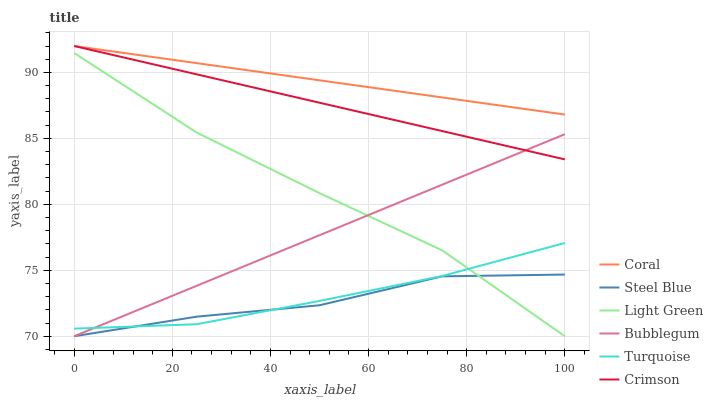Does Steel Blue have the minimum area under the curve?
Answer yes or no. Yes. Does Coral have the maximum area under the curve?
Answer yes or no. Yes. Does Coral have the minimum area under the curve?
Answer yes or no. No. Does Steel Blue have the maximum area under the curve?
Answer yes or no. No. Is Coral the smoothest?
Answer yes or no. Yes. Is Steel Blue the roughest?
Answer yes or no. Yes. Is Steel Blue the smoothest?
Answer yes or no. No. Is Coral the roughest?
Answer yes or no. No. Does Steel Blue have the lowest value?
Answer yes or no. Yes. Does Coral have the lowest value?
Answer yes or no. No. Does Crimson have the highest value?
Answer yes or no. Yes. Does Steel Blue have the highest value?
Answer yes or no. No. Is Light Green less than Coral?
Answer yes or no. Yes. Is Coral greater than Bubblegum?
Answer yes or no. Yes. Does Coral intersect Crimson?
Answer yes or no. Yes. Is Coral less than Crimson?
Answer yes or no. No. Is Coral greater than Crimson?
Answer yes or no. No. Does Light Green intersect Coral?
Answer yes or no. No. 